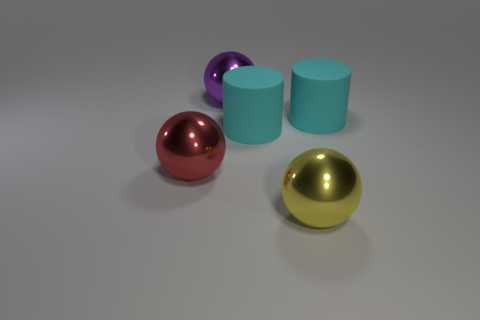Add 4 purple metallic objects. How many objects exist? 9 Subtract 2 spheres. How many spheres are left? 1 Subtract all red balls. How many balls are left? 2 Subtract 0 cyan spheres. How many objects are left? 5 Subtract all cylinders. How many objects are left? 3 Subtract all blue balls. Subtract all purple cubes. How many balls are left? 3 Subtract all cyan cubes. How many red balls are left? 1 Subtract all big cyan rubber things. Subtract all big cyan cylinders. How many objects are left? 1 Add 4 cyan rubber things. How many cyan rubber things are left? 6 Add 5 matte cylinders. How many matte cylinders exist? 7 